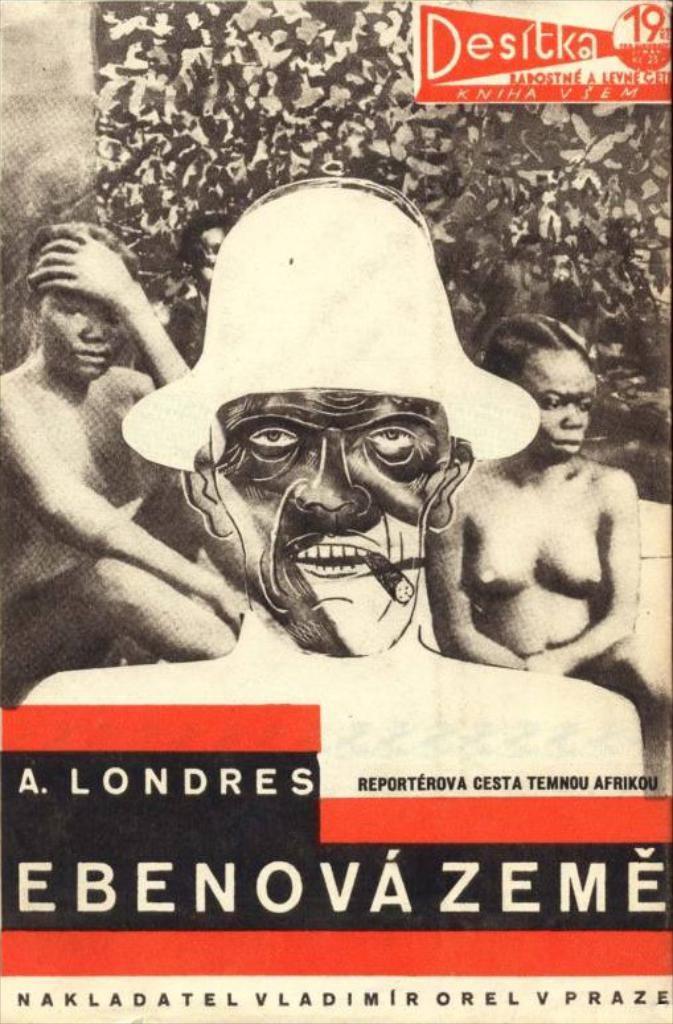Please provide a concise description of this image. In this image I can see it looks like an image on the book. There is the text at the bottom, there are two persons on either side of this image. 